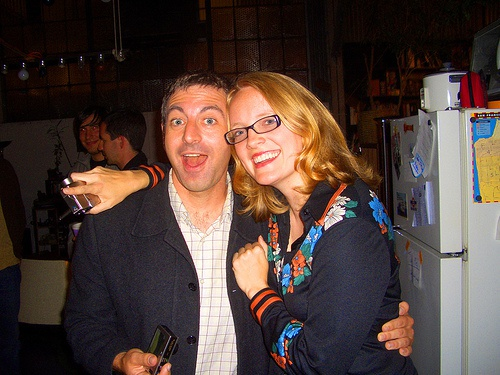Describe the objects in this image and their specific colors. I can see people in black, brown, and tan tones, people in black, lightgray, and salmon tones, refrigerator in black, darkgray, gray, and lightgray tones, people in black, maroon, and brown tones, and people in black and maroon tones in this image. 